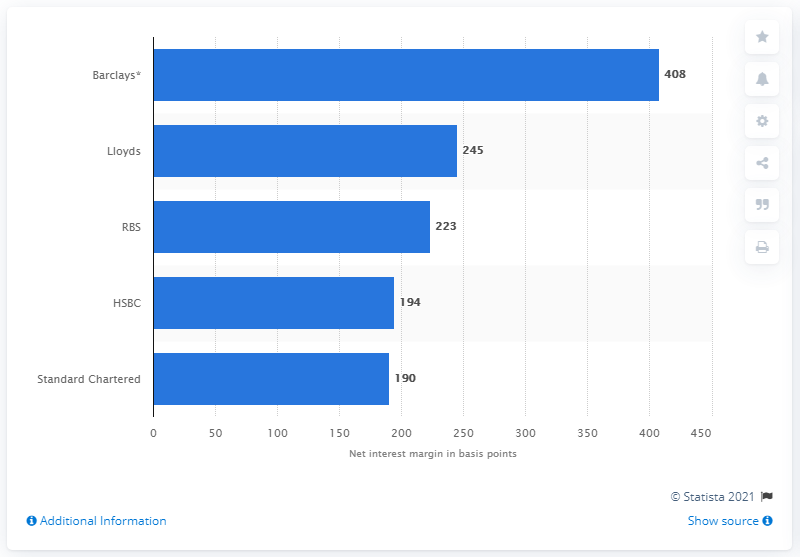Indicate a few pertinent items in this graphic. In 2013, Barclays' net interest margin was 408 points. 